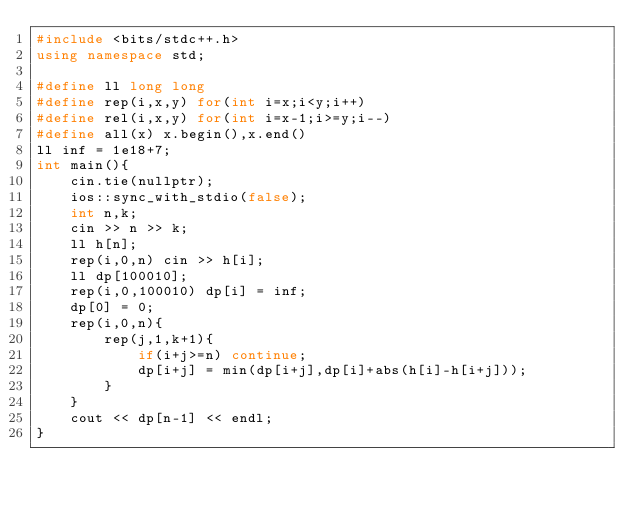<code> <loc_0><loc_0><loc_500><loc_500><_C++_>#include <bits/stdc++.h>
using namespace std;

#define ll long long
#define rep(i,x,y) for(int i=x;i<y;i++)
#define rel(i,x,y) for(int i=x-1;i>=y;i--)
#define all(x) x.begin(),x.end()
ll inf = 1e18+7;
int main(){
    cin.tie(nullptr);
    ios::sync_with_stdio(false);
    int n,k;
    cin >> n >> k; 
    ll h[n]; 
    rep(i,0,n) cin >> h[i]; 
    ll dp[100010];
    rep(i,0,100010) dp[i] = inf;
    dp[0] = 0;
    rep(i,0,n){
        rep(j,1,k+1){
            if(i+j>=n) continue;
            dp[i+j] = min(dp[i+j],dp[i]+abs(h[i]-h[i+j]));
        }
    }
    cout << dp[n-1] << endl;
}</code> 